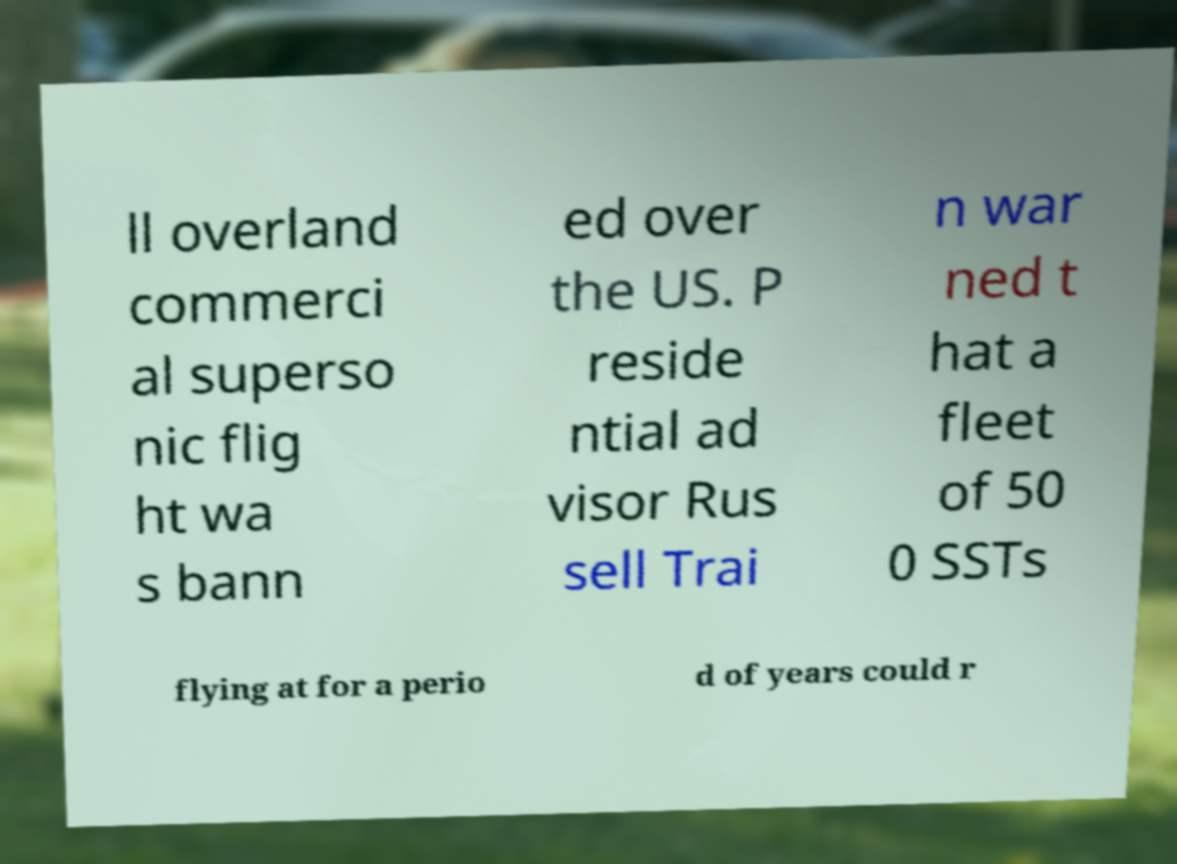Can you read and provide the text displayed in the image?This photo seems to have some interesting text. Can you extract and type it out for me? ll overland commerci al superso nic flig ht wa s bann ed over the US. P reside ntial ad visor Rus sell Trai n war ned t hat a fleet of 50 0 SSTs flying at for a perio d of years could r 